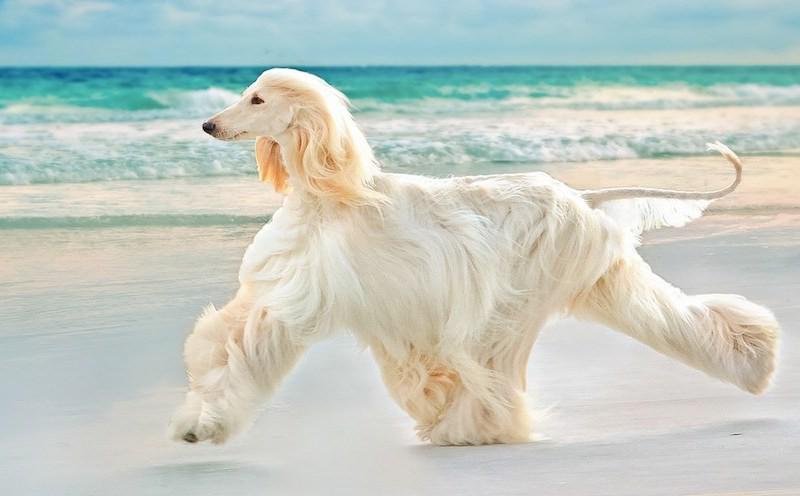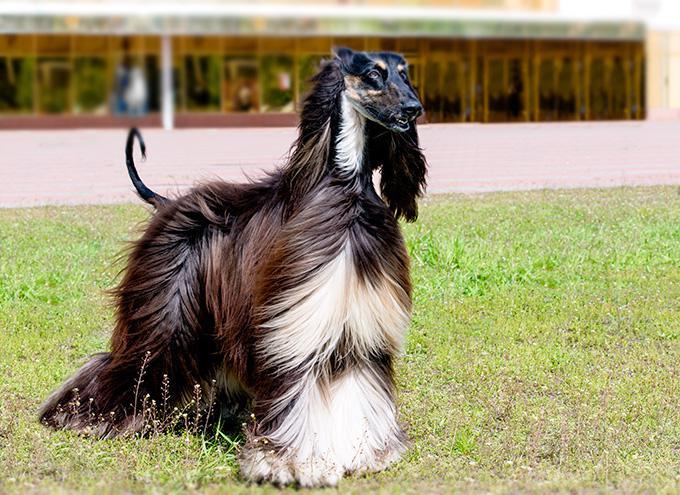The first image is the image on the left, the second image is the image on the right. For the images displayed, is the sentence "The hound on the left is more golden brown, and the one on the right is more cream colored." factually correct? Answer yes or no. No. 